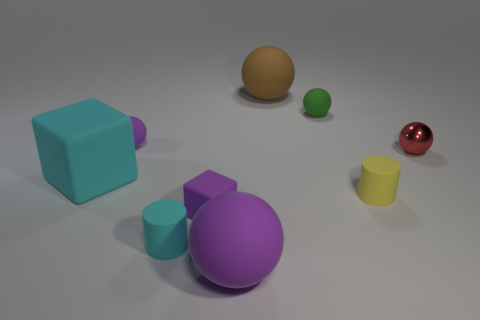The metal sphere has what color?
Your answer should be very brief. Red. Are there more big purple spheres right of the big brown sphere than tiny cylinders behind the small green matte object?
Your response must be concise. No. The large sphere behind the green rubber object is what color?
Your answer should be compact. Brown. Is the size of the purple ball in front of the big rubber block the same as the purple rubber object behind the small metallic ball?
Offer a terse response. No. What number of things are either objects or purple metallic balls?
Provide a succinct answer. 9. There is a small cylinder to the right of the big object behind the large block; what is its material?
Your answer should be very brief. Rubber. What number of cyan objects are the same shape as the yellow rubber thing?
Provide a succinct answer. 1. Is there a small matte block of the same color as the large cube?
Offer a very short reply. No. How many things are either tiny purple things that are in front of the tiny yellow cylinder or small rubber objects on the left side of the large purple sphere?
Keep it short and to the point. 3. There is a small purple thing behind the metallic object; are there any small cubes that are behind it?
Your answer should be very brief. No. 